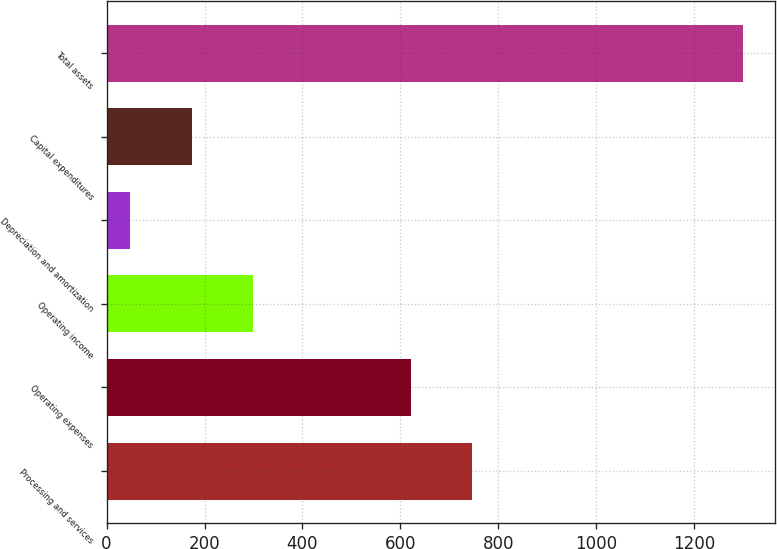Convert chart to OTSL. <chart><loc_0><loc_0><loc_500><loc_500><bar_chart><fcel>Processing and services<fcel>Operating expenses<fcel>Operating income<fcel>Depreciation and amortization<fcel>Capital expenditures<fcel>Total assets<nl><fcel>745.65<fcel>620.6<fcel>298.8<fcel>48.7<fcel>173.75<fcel>1299.2<nl></chart> 